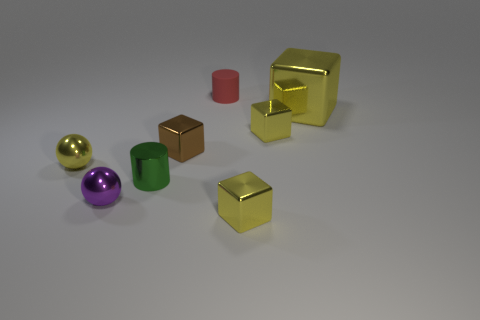Subtract all yellow blocks. How many were subtracted if there are1yellow blocks left? 2 Subtract all small brown shiny blocks. How many blocks are left? 3 Add 1 green cylinders. How many objects exist? 9 Subtract all brown cubes. How many cubes are left? 3 Subtract all cylinders. How many objects are left? 6 Subtract 0 green balls. How many objects are left? 8 Subtract 2 blocks. How many blocks are left? 2 Subtract all yellow cylinders. Subtract all cyan balls. How many cylinders are left? 2 Subtract all yellow blocks. How many brown cylinders are left? 0 Subtract all brown shiny cubes. Subtract all tiny cylinders. How many objects are left? 5 